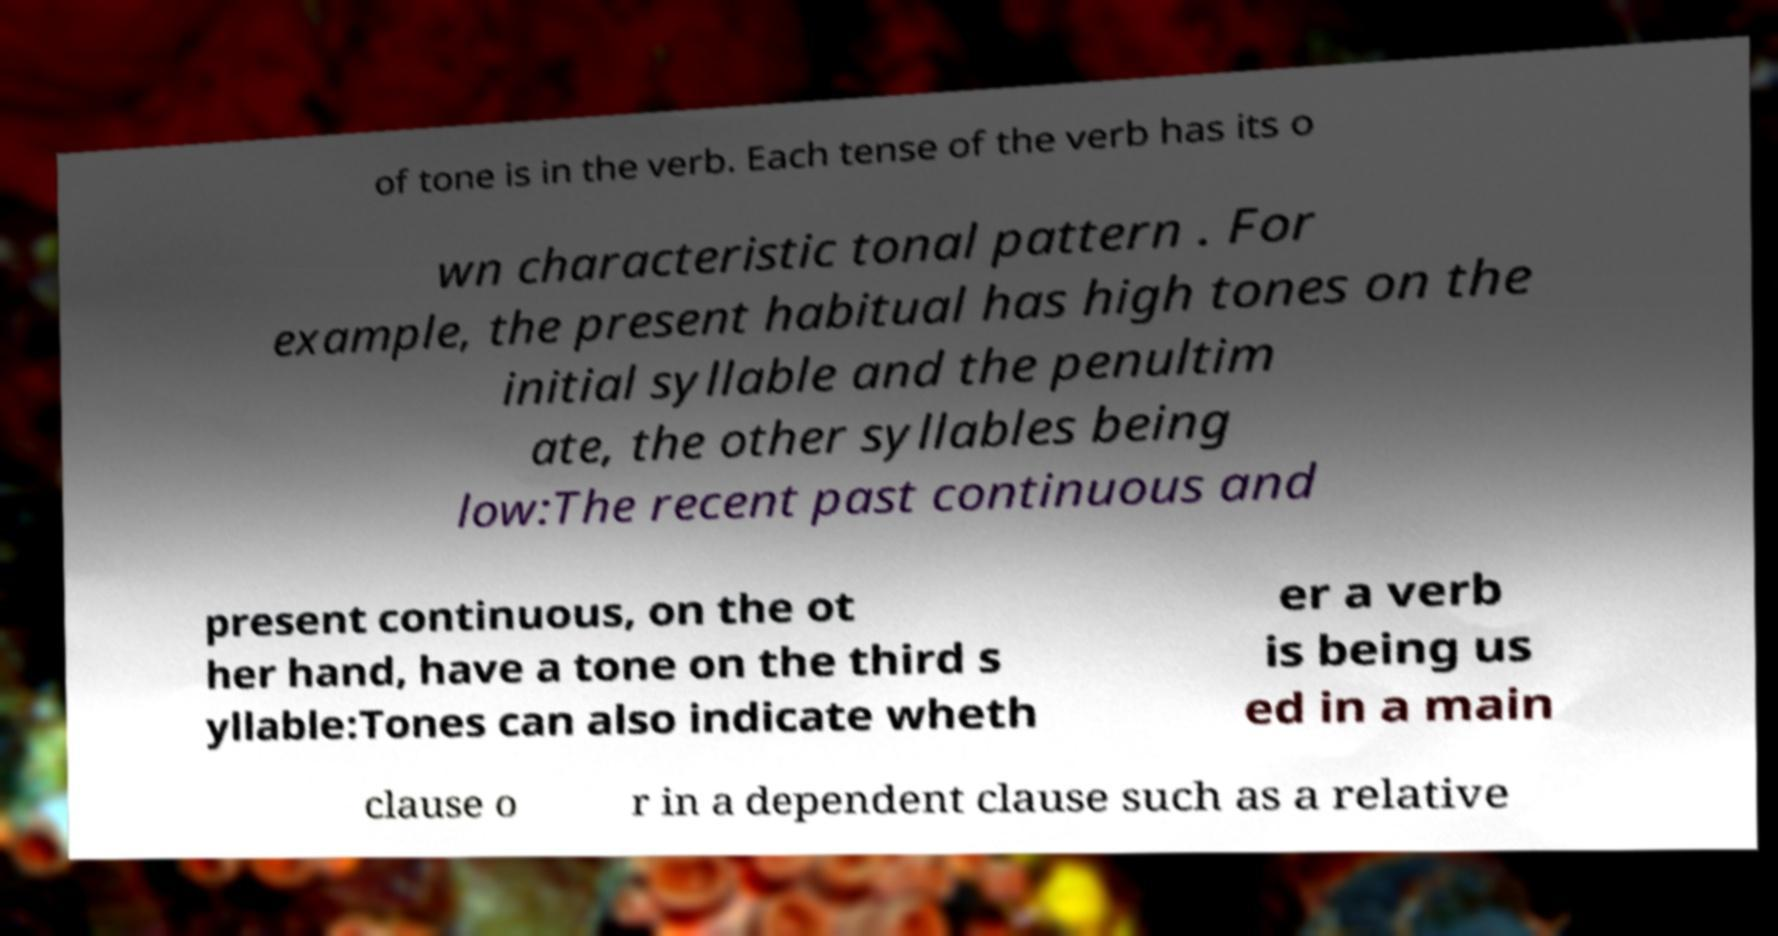What messages or text are displayed in this image? I need them in a readable, typed format. of tone is in the verb. Each tense of the verb has its o wn characteristic tonal pattern . For example, the present habitual has high tones on the initial syllable and the penultim ate, the other syllables being low:The recent past continuous and present continuous, on the ot her hand, have a tone on the third s yllable:Tones can also indicate wheth er a verb is being us ed in a main clause o r in a dependent clause such as a relative 